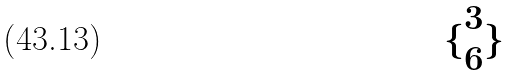Convert formula to latex. <formula><loc_0><loc_0><loc_500><loc_500>\{ \begin{matrix} 3 \\ 6 \end{matrix} \}</formula> 